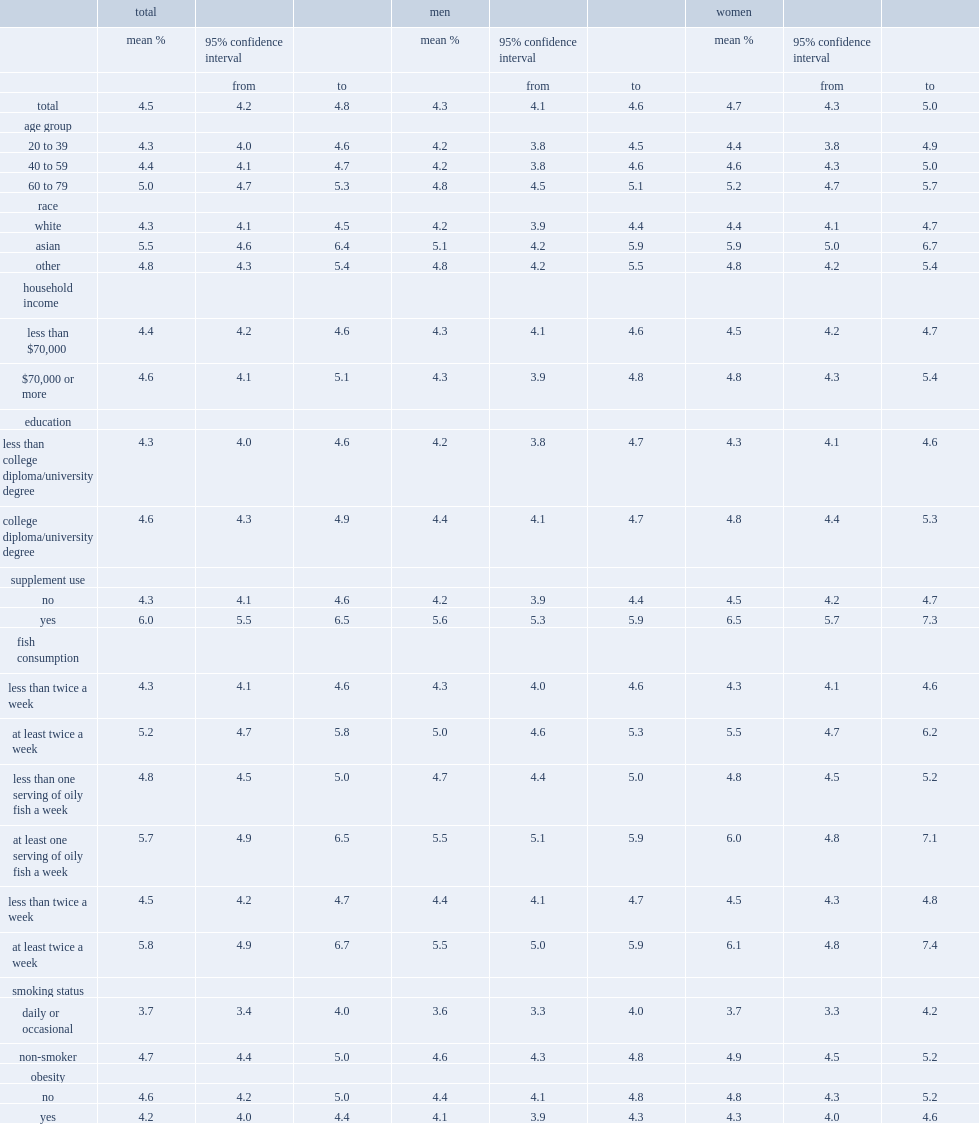In 2012/2013, what was the mean omega-3 index level of 20- to 79-year-olds? 4.5. 